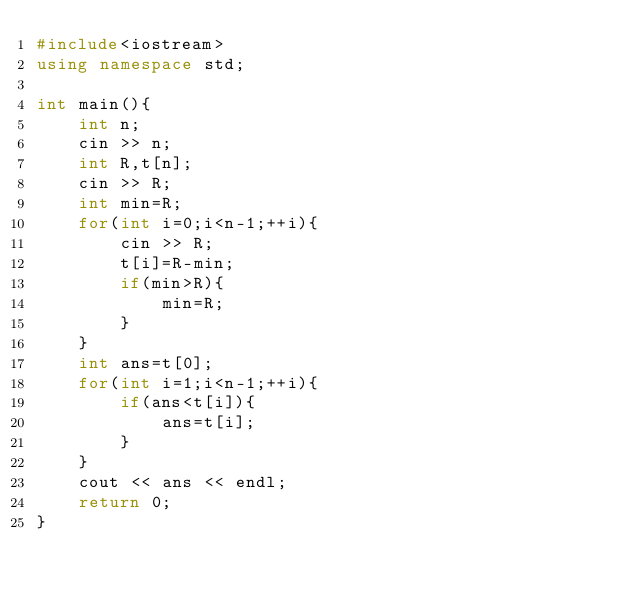Convert code to text. <code><loc_0><loc_0><loc_500><loc_500><_C++_>#include<iostream>
using namespace std;

int main(){
    int n;
    cin >> n;
    int R,t[n];
    cin >> R;
    int min=R;
    for(int i=0;i<n-1;++i){
        cin >> R;
        t[i]=R-min;
        if(min>R){
            min=R;
        }
    }
    int ans=t[0];
    for(int i=1;i<n-1;++i){
        if(ans<t[i]){
            ans=t[i];
        }
    }
    cout << ans << endl;
    return 0;
}
</code> 